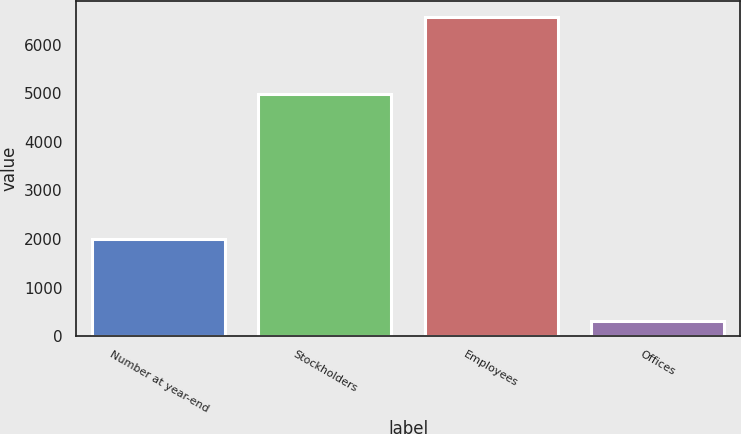Convert chart to OTSL. <chart><loc_0><loc_0><loc_500><loc_500><bar_chart><fcel>Number at year-end<fcel>Stockholders<fcel>Employees<fcel>Offices<nl><fcel>1999<fcel>4991<fcel>6569<fcel>310<nl></chart> 